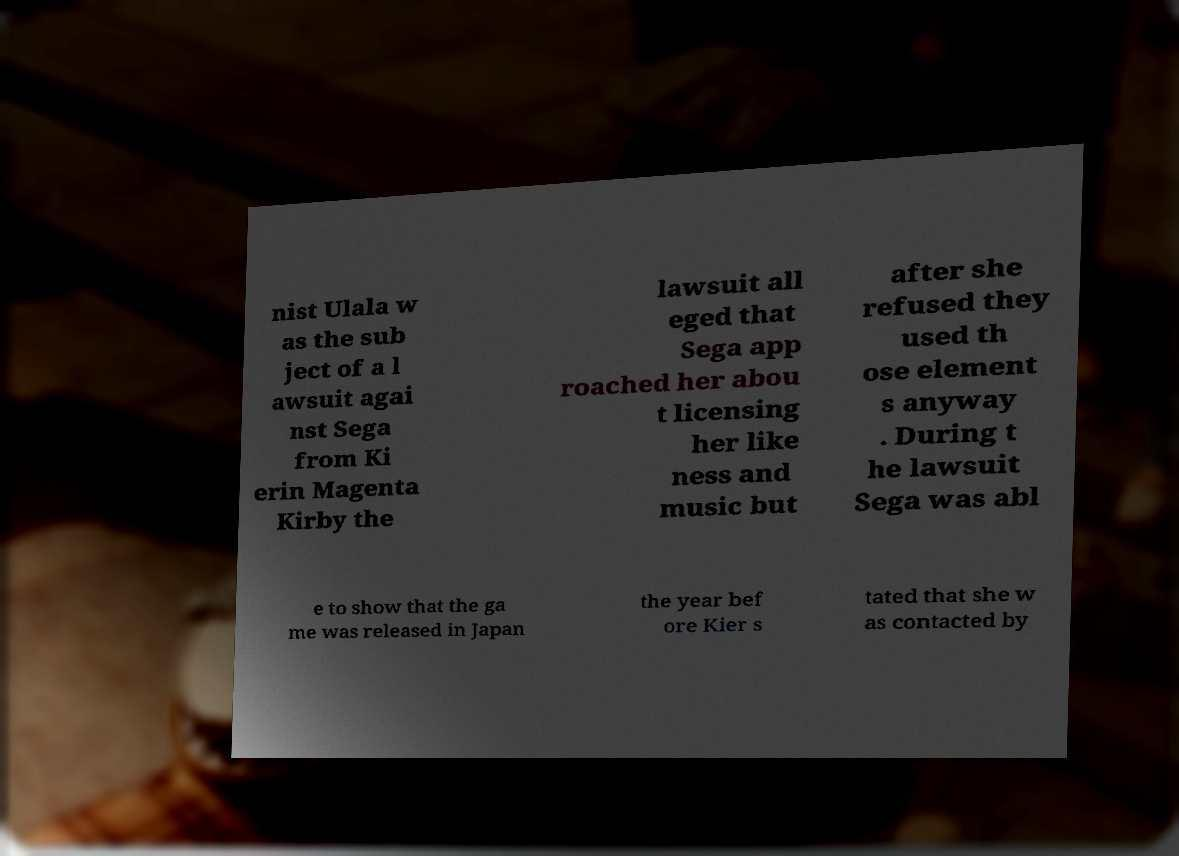What messages or text are displayed in this image? I need them in a readable, typed format. nist Ulala w as the sub ject of a l awsuit agai nst Sega from Ki erin Magenta Kirby the lawsuit all eged that Sega app roached her abou t licensing her like ness and music but after she refused they used th ose element s anyway . During t he lawsuit Sega was abl e to show that the ga me was released in Japan the year bef ore Kier s tated that she w as contacted by 